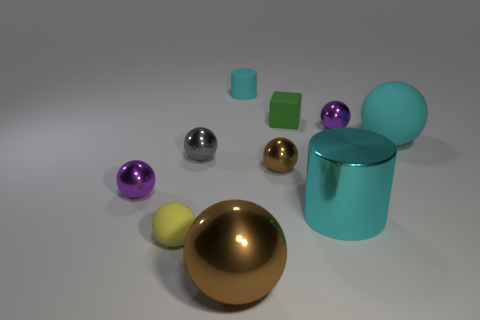What is the color of the big cylinder that is the same material as the large brown ball?
Provide a short and direct response. Cyan. What is the material of the tiny brown sphere?
Provide a short and direct response. Metal. The big cyan matte thing is what shape?
Keep it short and to the point. Sphere. What number of large spheres have the same color as the matte cylinder?
Your response must be concise. 1. There is a brown object on the right side of the big ball in front of the small purple sphere that is left of the small cyan rubber thing; what is it made of?
Your response must be concise. Metal. How many brown things are either large metallic balls or balls?
Offer a very short reply. 2. There is a purple metal sphere that is on the right side of the big shiny ball in front of the cyan matte object in front of the small matte block; how big is it?
Provide a succinct answer. Small. The other cyan object that is the same shape as the big cyan metal object is what size?
Your response must be concise. Small. What number of large objects are cubes or yellow spheres?
Your answer should be very brief. 0. Do the cyan cylinder that is in front of the big cyan rubber thing and the purple sphere that is to the right of the small green block have the same material?
Your answer should be very brief. Yes. 